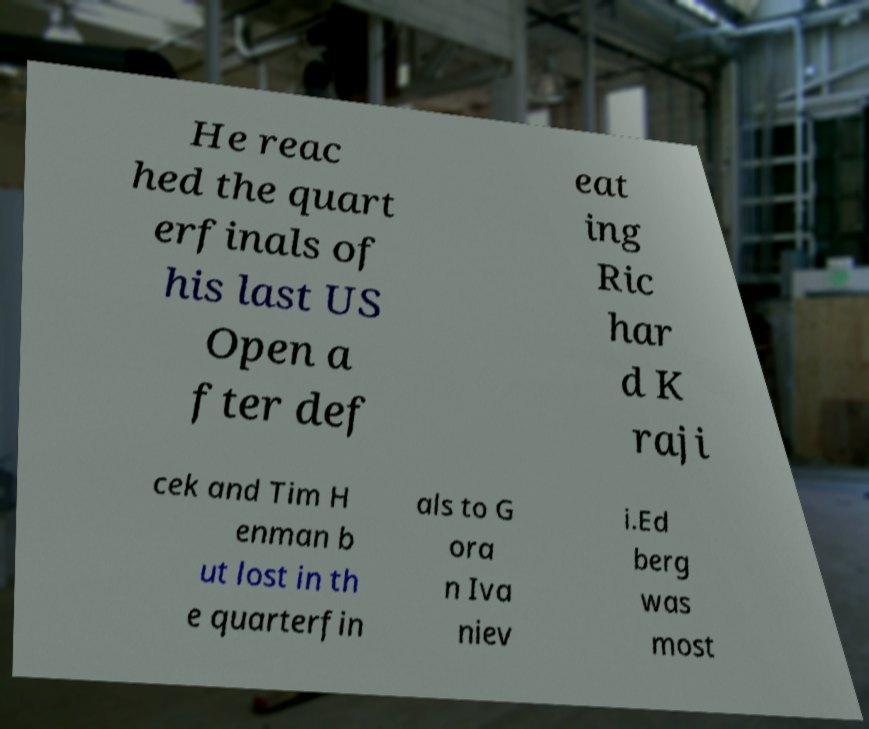Could you extract and type out the text from this image? He reac hed the quart erfinals of his last US Open a fter def eat ing Ric har d K raji cek and Tim H enman b ut lost in th e quarterfin als to G ora n Iva niev i.Ed berg was most 